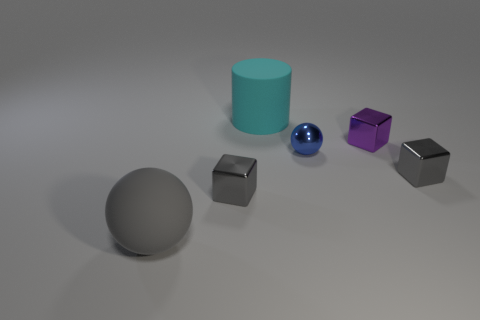How many other balls are the same size as the metallic ball?
Keep it short and to the point. 0. What number of things are either tiny things behind the blue shiny object or tiny blue shiny things?
Offer a terse response. 2. Are there fewer metallic things than things?
Your response must be concise. Yes. The cyan thing that is the same material as the large sphere is what shape?
Your answer should be compact. Cylinder. Are there any metallic blocks on the left side of the purple metal thing?
Keep it short and to the point. Yes. Are there fewer small purple things that are on the left side of the large cyan rubber object than tiny purple things?
Give a very brief answer. Yes. What is the material of the small purple object?
Make the answer very short. Metal. What is the color of the cylinder?
Make the answer very short. Cyan. What color is the small cube that is both to the right of the large cyan thing and in front of the purple thing?
Your response must be concise. Gray. Is there anything else that has the same material as the small blue sphere?
Make the answer very short. Yes. 